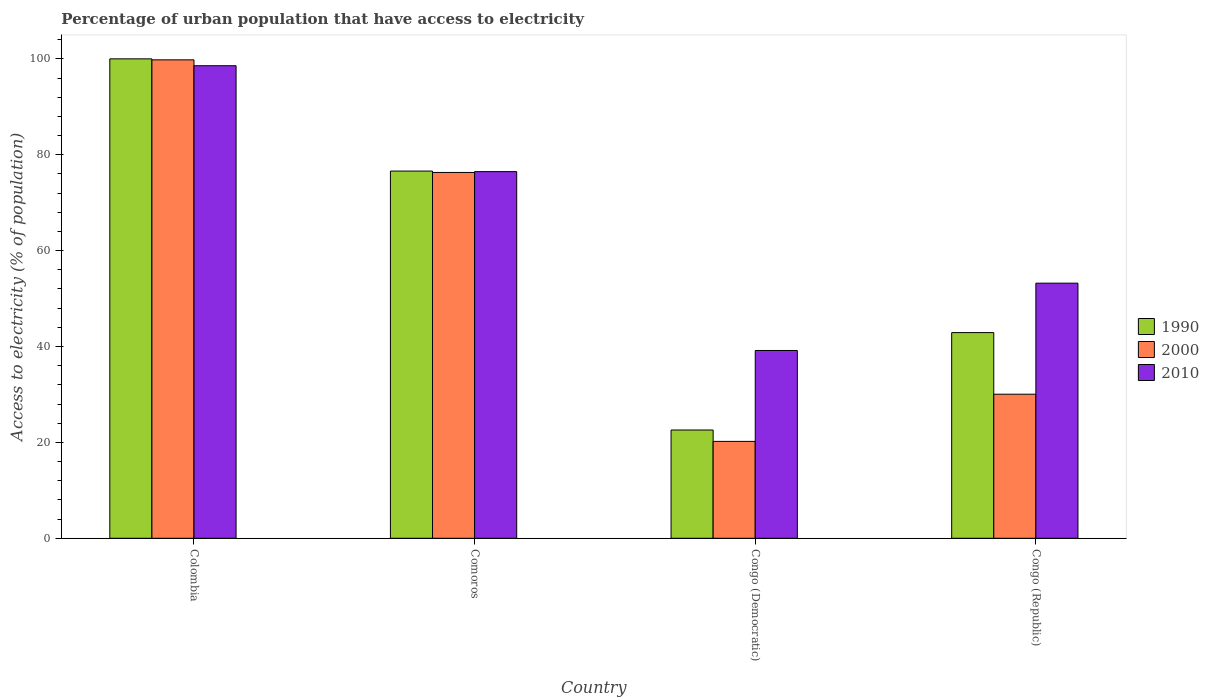How many different coloured bars are there?
Keep it short and to the point. 3. How many groups of bars are there?
Keep it short and to the point. 4. Are the number of bars per tick equal to the number of legend labels?
Provide a short and direct response. Yes. Are the number of bars on each tick of the X-axis equal?
Your answer should be compact. Yes. How many bars are there on the 2nd tick from the left?
Keep it short and to the point. 3. What is the label of the 4th group of bars from the left?
Your answer should be compact. Congo (Republic). In how many cases, is the number of bars for a given country not equal to the number of legend labels?
Ensure brevity in your answer.  0. What is the percentage of urban population that have access to electricity in 1990 in Colombia?
Your answer should be very brief. 100. Across all countries, what is the maximum percentage of urban population that have access to electricity in 1990?
Ensure brevity in your answer.  100. Across all countries, what is the minimum percentage of urban population that have access to electricity in 2010?
Your answer should be very brief. 39.17. In which country was the percentage of urban population that have access to electricity in 2000 maximum?
Keep it short and to the point. Colombia. In which country was the percentage of urban population that have access to electricity in 2000 minimum?
Give a very brief answer. Congo (Democratic). What is the total percentage of urban population that have access to electricity in 1990 in the graph?
Keep it short and to the point. 242.08. What is the difference between the percentage of urban population that have access to electricity in 2000 in Colombia and that in Congo (Democratic)?
Provide a short and direct response. 79.58. What is the difference between the percentage of urban population that have access to electricity in 1990 in Colombia and the percentage of urban population that have access to electricity in 2000 in Congo (Republic)?
Provide a succinct answer. 69.95. What is the average percentage of urban population that have access to electricity in 2000 per country?
Your answer should be compact. 56.59. What is the difference between the percentage of urban population that have access to electricity of/in 2000 and percentage of urban population that have access to electricity of/in 2010 in Comoros?
Give a very brief answer. -0.18. What is the ratio of the percentage of urban population that have access to electricity in 2010 in Congo (Democratic) to that in Congo (Republic)?
Give a very brief answer. 0.74. What is the difference between the highest and the second highest percentage of urban population that have access to electricity in 2010?
Your answer should be very brief. 22.08. What is the difference between the highest and the lowest percentage of urban population that have access to electricity in 1990?
Give a very brief answer. 77.42. In how many countries, is the percentage of urban population that have access to electricity in 2000 greater than the average percentage of urban population that have access to electricity in 2000 taken over all countries?
Keep it short and to the point. 2. What does the 2nd bar from the right in Congo (Democratic) represents?
Your answer should be very brief. 2000. How many bars are there?
Your answer should be very brief. 12. Are all the bars in the graph horizontal?
Make the answer very short. No. Does the graph contain grids?
Provide a short and direct response. No. How are the legend labels stacked?
Provide a short and direct response. Vertical. What is the title of the graph?
Your answer should be compact. Percentage of urban population that have access to electricity. What is the label or title of the X-axis?
Your answer should be compact. Country. What is the label or title of the Y-axis?
Ensure brevity in your answer.  Access to electricity (% of population). What is the Access to electricity (% of population) in 2000 in Colombia?
Your response must be concise. 99.79. What is the Access to electricity (% of population) of 2010 in Colombia?
Keep it short and to the point. 98.56. What is the Access to electricity (% of population) in 1990 in Comoros?
Make the answer very short. 76.59. What is the Access to electricity (% of population) of 2000 in Comoros?
Provide a succinct answer. 76.3. What is the Access to electricity (% of population) in 2010 in Comoros?
Offer a terse response. 76.48. What is the Access to electricity (% of population) in 1990 in Congo (Democratic)?
Make the answer very short. 22.58. What is the Access to electricity (% of population) of 2000 in Congo (Democratic)?
Your response must be concise. 20.21. What is the Access to electricity (% of population) of 2010 in Congo (Democratic)?
Provide a succinct answer. 39.17. What is the Access to electricity (% of population) of 1990 in Congo (Republic)?
Provide a succinct answer. 42.9. What is the Access to electricity (% of population) of 2000 in Congo (Republic)?
Keep it short and to the point. 30.05. What is the Access to electricity (% of population) of 2010 in Congo (Republic)?
Offer a very short reply. 53.21. Across all countries, what is the maximum Access to electricity (% of population) of 1990?
Your answer should be very brief. 100. Across all countries, what is the maximum Access to electricity (% of population) of 2000?
Provide a short and direct response. 99.79. Across all countries, what is the maximum Access to electricity (% of population) in 2010?
Your response must be concise. 98.56. Across all countries, what is the minimum Access to electricity (% of population) of 1990?
Give a very brief answer. 22.58. Across all countries, what is the minimum Access to electricity (% of population) in 2000?
Keep it short and to the point. 20.21. Across all countries, what is the minimum Access to electricity (% of population) in 2010?
Your answer should be very brief. 39.17. What is the total Access to electricity (% of population) of 1990 in the graph?
Provide a short and direct response. 242.08. What is the total Access to electricity (% of population) in 2000 in the graph?
Ensure brevity in your answer.  226.35. What is the total Access to electricity (% of population) of 2010 in the graph?
Your answer should be very brief. 267.43. What is the difference between the Access to electricity (% of population) of 1990 in Colombia and that in Comoros?
Your answer should be very brief. 23.41. What is the difference between the Access to electricity (% of population) of 2000 in Colombia and that in Comoros?
Provide a succinct answer. 23.49. What is the difference between the Access to electricity (% of population) in 2010 in Colombia and that in Comoros?
Offer a very short reply. 22.08. What is the difference between the Access to electricity (% of population) in 1990 in Colombia and that in Congo (Democratic)?
Offer a very short reply. 77.42. What is the difference between the Access to electricity (% of population) of 2000 in Colombia and that in Congo (Democratic)?
Provide a succinct answer. 79.58. What is the difference between the Access to electricity (% of population) in 2010 in Colombia and that in Congo (Democratic)?
Keep it short and to the point. 59.39. What is the difference between the Access to electricity (% of population) of 1990 in Colombia and that in Congo (Republic)?
Give a very brief answer. 57.1. What is the difference between the Access to electricity (% of population) of 2000 in Colombia and that in Congo (Republic)?
Your answer should be compact. 69.74. What is the difference between the Access to electricity (% of population) in 2010 in Colombia and that in Congo (Republic)?
Your answer should be compact. 45.35. What is the difference between the Access to electricity (% of population) of 1990 in Comoros and that in Congo (Democratic)?
Give a very brief answer. 54.01. What is the difference between the Access to electricity (% of population) of 2000 in Comoros and that in Congo (Democratic)?
Provide a short and direct response. 56.09. What is the difference between the Access to electricity (% of population) of 2010 in Comoros and that in Congo (Democratic)?
Make the answer very short. 37.31. What is the difference between the Access to electricity (% of population) of 1990 in Comoros and that in Congo (Republic)?
Your answer should be compact. 33.69. What is the difference between the Access to electricity (% of population) in 2000 in Comoros and that in Congo (Republic)?
Give a very brief answer. 46.26. What is the difference between the Access to electricity (% of population) of 2010 in Comoros and that in Congo (Republic)?
Offer a very short reply. 23.27. What is the difference between the Access to electricity (% of population) of 1990 in Congo (Democratic) and that in Congo (Republic)?
Your answer should be compact. -20.32. What is the difference between the Access to electricity (% of population) in 2000 in Congo (Democratic) and that in Congo (Republic)?
Ensure brevity in your answer.  -9.84. What is the difference between the Access to electricity (% of population) in 2010 in Congo (Democratic) and that in Congo (Republic)?
Provide a short and direct response. -14.04. What is the difference between the Access to electricity (% of population) of 1990 in Colombia and the Access to electricity (% of population) of 2000 in Comoros?
Ensure brevity in your answer.  23.7. What is the difference between the Access to electricity (% of population) in 1990 in Colombia and the Access to electricity (% of population) in 2010 in Comoros?
Your answer should be very brief. 23.52. What is the difference between the Access to electricity (% of population) of 2000 in Colombia and the Access to electricity (% of population) of 2010 in Comoros?
Provide a succinct answer. 23.31. What is the difference between the Access to electricity (% of population) in 1990 in Colombia and the Access to electricity (% of population) in 2000 in Congo (Democratic)?
Offer a very short reply. 79.79. What is the difference between the Access to electricity (% of population) of 1990 in Colombia and the Access to electricity (% of population) of 2010 in Congo (Democratic)?
Your answer should be very brief. 60.83. What is the difference between the Access to electricity (% of population) in 2000 in Colombia and the Access to electricity (% of population) in 2010 in Congo (Democratic)?
Provide a short and direct response. 60.62. What is the difference between the Access to electricity (% of population) of 1990 in Colombia and the Access to electricity (% of population) of 2000 in Congo (Republic)?
Your response must be concise. 69.95. What is the difference between the Access to electricity (% of population) in 1990 in Colombia and the Access to electricity (% of population) in 2010 in Congo (Republic)?
Your answer should be compact. 46.79. What is the difference between the Access to electricity (% of population) in 2000 in Colombia and the Access to electricity (% of population) in 2010 in Congo (Republic)?
Provide a short and direct response. 46.58. What is the difference between the Access to electricity (% of population) of 1990 in Comoros and the Access to electricity (% of population) of 2000 in Congo (Democratic)?
Ensure brevity in your answer.  56.38. What is the difference between the Access to electricity (% of population) of 1990 in Comoros and the Access to electricity (% of population) of 2010 in Congo (Democratic)?
Give a very brief answer. 37.42. What is the difference between the Access to electricity (% of population) in 2000 in Comoros and the Access to electricity (% of population) in 2010 in Congo (Democratic)?
Make the answer very short. 37.13. What is the difference between the Access to electricity (% of population) of 1990 in Comoros and the Access to electricity (% of population) of 2000 in Congo (Republic)?
Your answer should be very brief. 46.54. What is the difference between the Access to electricity (% of population) in 1990 in Comoros and the Access to electricity (% of population) in 2010 in Congo (Republic)?
Your response must be concise. 23.38. What is the difference between the Access to electricity (% of population) in 2000 in Comoros and the Access to electricity (% of population) in 2010 in Congo (Republic)?
Offer a terse response. 23.09. What is the difference between the Access to electricity (% of population) of 1990 in Congo (Democratic) and the Access to electricity (% of population) of 2000 in Congo (Republic)?
Your answer should be very brief. -7.46. What is the difference between the Access to electricity (% of population) of 1990 in Congo (Democratic) and the Access to electricity (% of population) of 2010 in Congo (Republic)?
Your answer should be compact. -30.63. What is the difference between the Access to electricity (% of population) of 2000 in Congo (Democratic) and the Access to electricity (% of population) of 2010 in Congo (Republic)?
Your answer should be compact. -33. What is the average Access to electricity (% of population) in 1990 per country?
Keep it short and to the point. 60.52. What is the average Access to electricity (% of population) of 2000 per country?
Provide a succinct answer. 56.59. What is the average Access to electricity (% of population) in 2010 per country?
Your response must be concise. 66.86. What is the difference between the Access to electricity (% of population) in 1990 and Access to electricity (% of population) in 2000 in Colombia?
Your answer should be very brief. 0.21. What is the difference between the Access to electricity (% of population) in 1990 and Access to electricity (% of population) in 2010 in Colombia?
Offer a terse response. 1.44. What is the difference between the Access to electricity (% of population) in 2000 and Access to electricity (% of population) in 2010 in Colombia?
Offer a very short reply. 1.22. What is the difference between the Access to electricity (% of population) of 1990 and Access to electricity (% of population) of 2000 in Comoros?
Ensure brevity in your answer.  0.29. What is the difference between the Access to electricity (% of population) in 2000 and Access to electricity (% of population) in 2010 in Comoros?
Offer a terse response. -0.18. What is the difference between the Access to electricity (% of population) in 1990 and Access to electricity (% of population) in 2000 in Congo (Democratic)?
Ensure brevity in your answer.  2.37. What is the difference between the Access to electricity (% of population) of 1990 and Access to electricity (% of population) of 2010 in Congo (Democratic)?
Your answer should be very brief. -16.59. What is the difference between the Access to electricity (% of population) in 2000 and Access to electricity (% of population) in 2010 in Congo (Democratic)?
Ensure brevity in your answer.  -18.96. What is the difference between the Access to electricity (% of population) of 1990 and Access to electricity (% of population) of 2000 in Congo (Republic)?
Your response must be concise. 12.85. What is the difference between the Access to electricity (% of population) of 1990 and Access to electricity (% of population) of 2010 in Congo (Republic)?
Ensure brevity in your answer.  -10.31. What is the difference between the Access to electricity (% of population) in 2000 and Access to electricity (% of population) in 2010 in Congo (Republic)?
Make the answer very short. -23.16. What is the ratio of the Access to electricity (% of population) of 1990 in Colombia to that in Comoros?
Offer a terse response. 1.31. What is the ratio of the Access to electricity (% of population) of 2000 in Colombia to that in Comoros?
Make the answer very short. 1.31. What is the ratio of the Access to electricity (% of population) in 2010 in Colombia to that in Comoros?
Give a very brief answer. 1.29. What is the ratio of the Access to electricity (% of population) of 1990 in Colombia to that in Congo (Democratic)?
Make the answer very short. 4.43. What is the ratio of the Access to electricity (% of population) of 2000 in Colombia to that in Congo (Democratic)?
Your response must be concise. 4.94. What is the ratio of the Access to electricity (% of population) of 2010 in Colombia to that in Congo (Democratic)?
Offer a terse response. 2.52. What is the ratio of the Access to electricity (% of population) in 1990 in Colombia to that in Congo (Republic)?
Ensure brevity in your answer.  2.33. What is the ratio of the Access to electricity (% of population) in 2000 in Colombia to that in Congo (Republic)?
Ensure brevity in your answer.  3.32. What is the ratio of the Access to electricity (% of population) of 2010 in Colombia to that in Congo (Republic)?
Your response must be concise. 1.85. What is the ratio of the Access to electricity (% of population) in 1990 in Comoros to that in Congo (Democratic)?
Your answer should be compact. 3.39. What is the ratio of the Access to electricity (% of population) of 2000 in Comoros to that in Congo (Democratic)?
Provide a succinct answer. 3.78. What is the ratio of the Access to electricity (% of population) in 2010 in Comoros to that in Congo (Democratic)?
Provide a succinct answer. 1.95. What is the ratio of the Access to electricity (% of population) in 1990 in Comoros to that in Congo (Republic)?
Make the answer very short. 1.79. What is the ratio of the Access to electricity (% of population) in 2000 in Comoros to that in Congo (Republic)?
Offer a very short reply. 2.54. What is the ratio of the Access to electricity (% of population) of 2010 in Comoros to that in Congo (Republic)?
Your answer should be very brief. 1.44. What is the ratio of the Access to electricity (% of population) in 1990 in Congo (Democratic) to that in Congo (Republic)?
Offer a terse response. 0.53. What is the ratio of the Access to electricity (% of population) in 2000 in Congo (Democratic) to that in Congo (Republic)?
Provide a short and direct response. 0.67. What is the ratio of the Access to electricity (% of population) of 2010 in Congo (Democratic) to that in Congo (Republic)?
Give a very brief answer. 0.74. What is the difference between the highest and the second highest Access to electricity (% of population) of 1990?
Provide a short and direct response. 23.41. What is the difference between the highest and the second highest Access to electricity (% of population) of 2000?
Your answer should be compact. 23.49. What is the difference between the highest and the second highest Access to electricity (% of population) in 2010?
Your answer should be very brief. 22.08. What is the difference between the highest and the lowest Access to electricity (% of population) in 1990?
Offer a terse response. 77.42. What is the difference between the highest and the lowest Access to electricity (% of population) of 2000?
Your response must be concise. 79.58. What is the difference between the highest and the lowest Access to electricity (% of population) in 2010?
Provide a succinct answer. 59.39. 